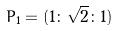Convert formula to latex. <formula><loc_0><loc_0><loc_500><loc_500>P _ { 1 } = ( 1 \colon \sqrt { 2 } \colon 1 )</formula> 